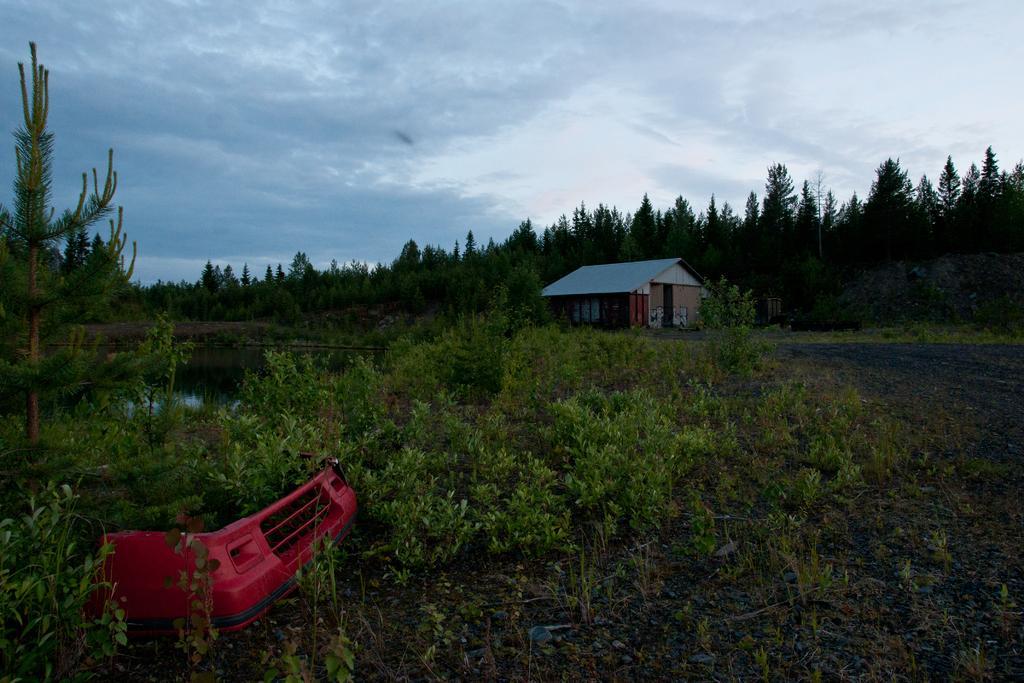Describe this image in one or two sentences. In this image I see the plants and I see the red color thing over here and I see the water over here. In the background I see a house and I see the trees and I see the sky which is cloudy. 